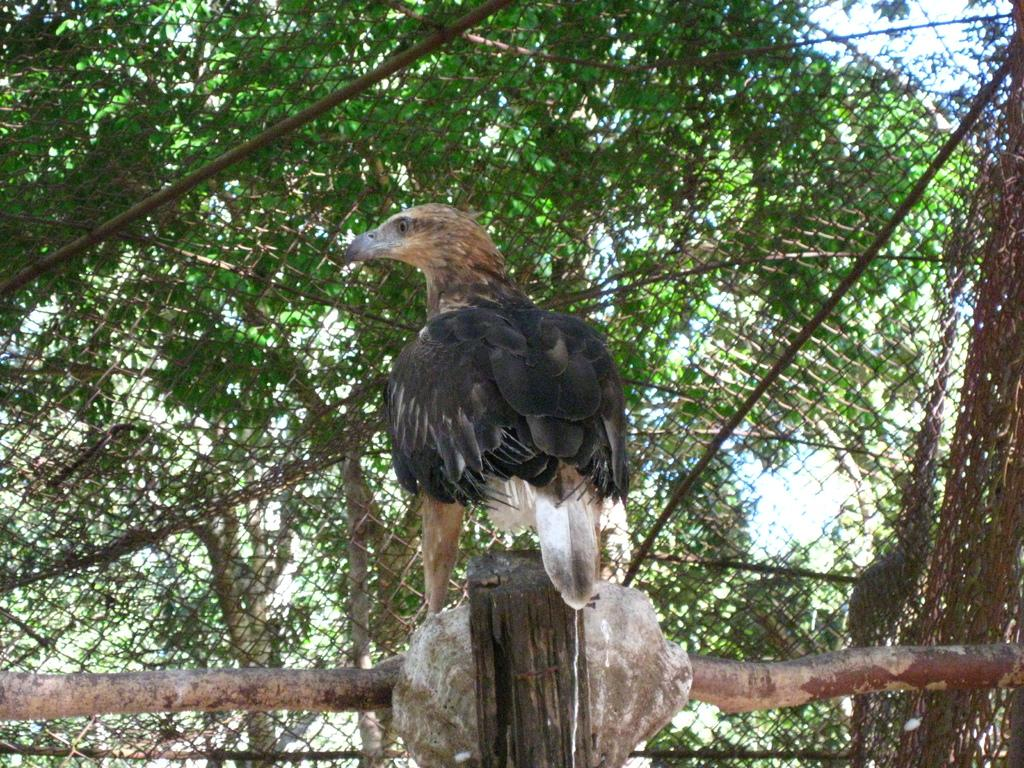What type of animal is in the image? There is a bird in the image. What is the bird standing on? The bird is standing on a wooden rod. What can be seen in the background of the image? There are trees in the background of the image. What rule does the bird follow while standing on the wooden rod? There is no rule mentioned or implied in the image, as it simply shows a bird standing on a wooden rod. 